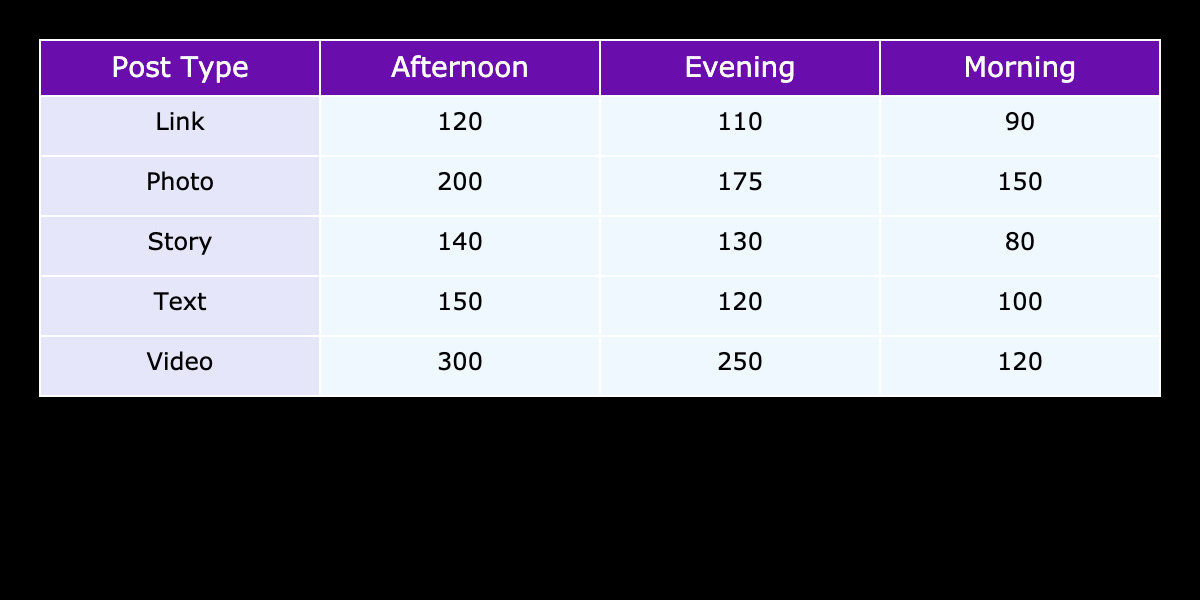What is the total engagement for Video posts in the Afternoon? The engagement for Video posts in the Afternoon is listed directly in the table as 300.
Answer: 300 Which post type received the highest engagement in the Evening? Looking at the Evening column, the Post Types and their corresponding engagement scores are as follows: Photo (175), Video (250), Text (120), Link (110), and Story (130). The highest score in this column is 250 for Video.
Answer: Video What is the average engagement for all post types in the Morning? The engagements for Morning are Photo (150), Video (120), Text (100), Link (90), and Story (80). Adding these together gives 150 + 120 + 100 + 90 + 80 = 540. There are 5 post types, so the average is 540 / 5 = 108.
Answer: 108 Is the engagement for Link posts in the Afternoon greater than the engagement for Text posts in the Evening? The engagement for Link posts in the Afternoon is 120 and for Text posts in the Evening is 120 as well. Since both values are equal, the statement is false.
Answer: No What is the sum of the engagement values for all post types in the Afternoon? The engagement values in the Afternoon are: Photo (200), Video (300), Text (150), Link (120), and Story (140). Adding these gives 200 + 300 + 150 + 120 + 140 = 910.
Answer: 910 Which time of day has the lowest total engagement across all post types? The engagement totals by time of day are: Morning (150 + 120 + 100 + 90 + 80 = 540), Afternoon (200 + 300 + 150 + 120 + 140 = 910), and Evening (175 + 250 + 120 + 110 + 130 = 785). The lowest total is 540 for Morning.
Answer: Morning Did any post type have an engagement value greater than 200 during the Afternoon? The values for the Afternoon are: Photo (200), Video (300), Text (150), Link (120), and Story (140). Video has a value greater than 200, so the statement is true.
Answer: Yes What is the difference in engagement between the highest and lowest performing post types in the Evening? In the Evening, the highest is Video (250) and the lowest is Text (120). The difference is calculated as 250 - 120 = 130.
Answer: 130 How does the total engagement for Story posts compare to the total engagement for Photo posts across all times? The total engagement for Story posts is 80 + 140 + 130 = 350, and for Photo posts it is 150 + 200 + 175 = 525. The comparison shows that Photo posts have higher engagement by 525 - 350 = 175.
Answer: Higher by 175 